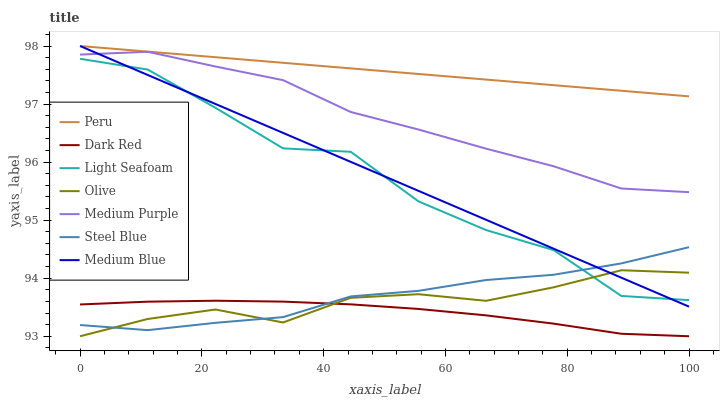Does Dark Red have the minimum area under the curve?
Answer yes or no. Yes. Does Peru have the maximum area under the curve?
Answer yes or no. Yes. Does Medium Blue have the minimum area under the curve?
Answer yes or no. No. Does Medium Blue have the maximum area under the curve?
Answer yes or no. No. Is Medium Blue the smoothest?
Answer yes or no. Yes. Is Light Seafoam the roughest?
Answer yes or no. Yes. Is Steel Blue the smoothest?
Answer yes or no. No. Is Steel Blue the roughest?
Answer yes or no. No. Does Dark Red have the lowest value?
Answer yes or no. Yes. Does Medium Blue have the lowest value?
Answer yes or no. No. Does Peru have the highest value?
Answer yes or no. Yes. Does Steel Blue have the highest value?
Answer yes or no. No. Is Olive less than Medium Purple?
Answer yes or no. Yes. Is Medium Blue greater than Dark Red?
Answer yes or no. Yes. Does Light Seafoam intersect Medium Blue?
Answer yes or no. Yes. Is Light Seafoam less than Medium Blue?
Answer yes or no. No. Is Light Seafoam greater than Medium Blue?
Answer yes or no. No. Does Olive intersect Medium Purple?
Answer yes or no. No. 